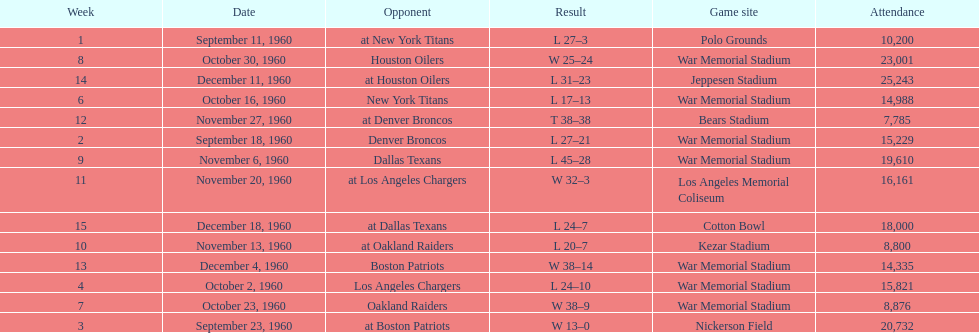How many times was war memorial stadium the game site? 6. Could you parse the entire table as a dict? {'header': ['Week', 'Date', 'Opponent', 'Result', 'Game site', 'Attendance'], 'rows': [['1', 'September 11, 1960', 'at New York Titans', 'L 27–3', 'Polo Grounds', '10,200'], ['8', 'October 30, 1960', 'Houston Oilers', 'W 25–24', 'War Memorial Stadium', '23,001'], ['14', 'December 11, 1960', 'at Houston Oilers', 'L 31–23', 'Jeppesen Stadium', '25,243'], ['6', 'October 16, 1960', 'New York Titans', 'L 17–13', 'War Memorial Stadium', '14,988'], ['12', 'November 27, 1960', 'at Denver Broncos', 'T 38–38', 'Bears Stadium', '7,785'], ['2', 'September 18, 1960', 'Denver Broncos', 'L 27–21', 'War Memorial Stadium', '15,229'], ['9', 'November 6, 1960', 'Dallas Texans', 'L 45–28', 'War Memorial Stadium', '19,610'], ['11', 'November 20, 1960', 'at Los Angeles Chargers', 'W 32–3', 'Los Angeles Memorial Coliseum', '16,161'], ['15', 'December 18, 1960', 'at Dallas Texans', 'L 24–7', 'Cotton Bowl', '18,000'], ['10', 'November 13, 1960', 'at Oakland Raiders', 'L 20–7', 'Kezar Stadium', '8,800'], ['13', 'December 4, 1960', 'Boston Patriots', 'W 38–14', 'War Memorial Stadium', '14,335'], ['4', 'October 2, 1960', 'Los Angeles Chargers', 'L 24–10', 'War Memorial Stadium', '15,821'], ['7', 'October 23, 1960', 'Oakland Raiders', 'W 38–9', 'War Memorial Stadium', '8,876'], ['3', 'September 23, 1960', 'at Boston Patriots', 'W 13–0', 'Nickerson Field', '20,732']]} 